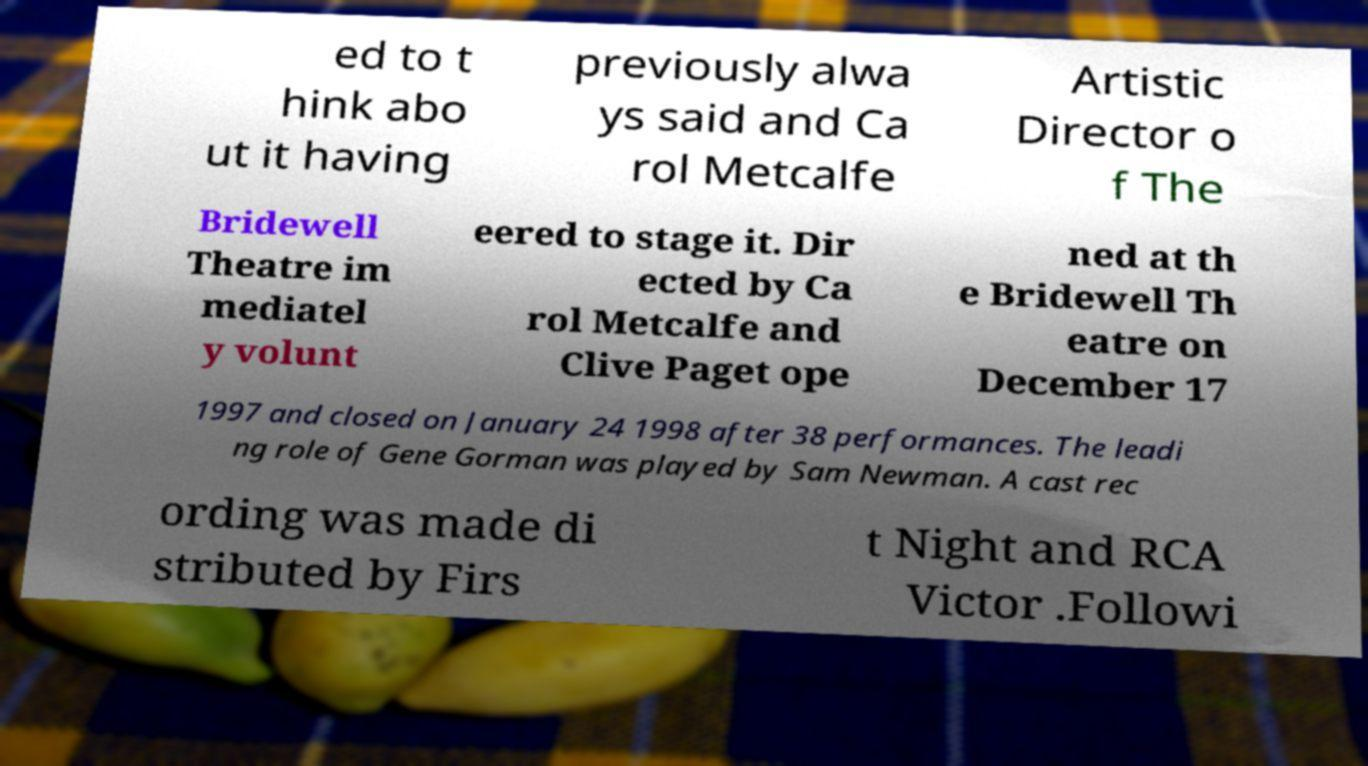There's text embedded in this image that I need extracted. Can you transcribe it verbatim? ed to t hink abo ut it having previously alwa ys said and Ca rol Metcalfe Artistic Director o f The Bridewell Theatre im mediatel y volunt eered to stage it. Dir ected by Ca rol Metcalfe and Clive Paget ope ned at th e Bridewell Th eatre on December 17 1997 and closed on January 24 1998 after 38 performances. The leadi ng role of Gene Gorman was played by Sam Newman. A cast rec ording was made di stributed by Firs t Night and RCA Victor .Followi 